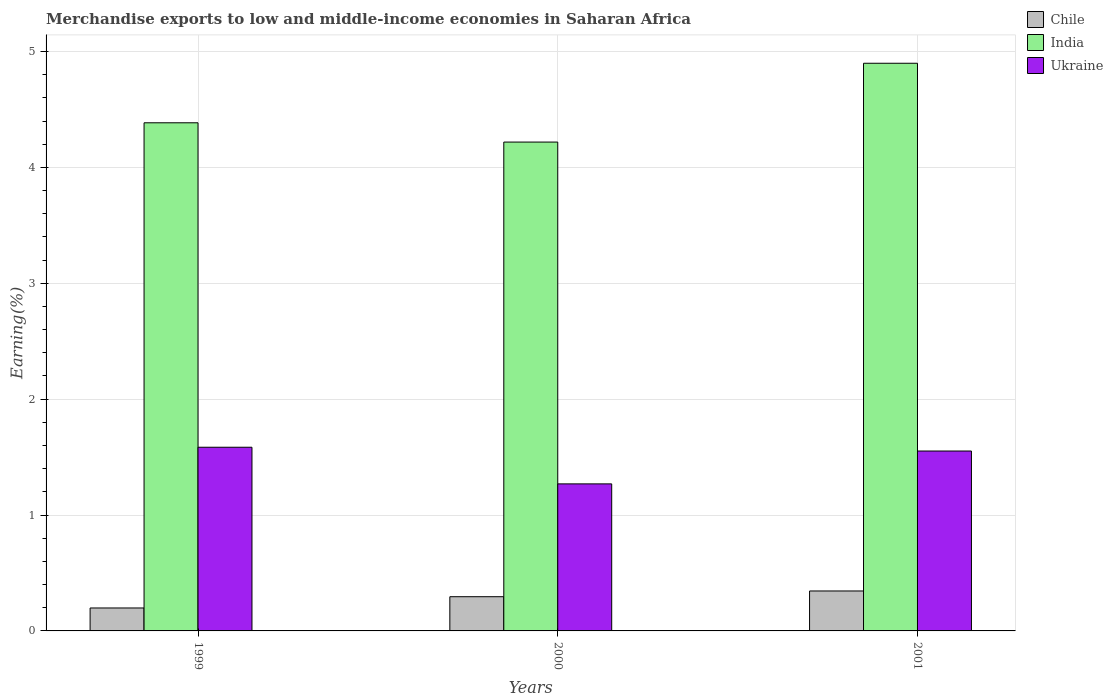How many different coloured bars are there?
Make the answer very short. 3. How many groups of bars are there?
Provide a short and direct response. 3. Are the number of bars per tick equal to the number of legend labels?
Provide a short and direct response. Yes. Are the number of bars on each tick of the X-axis equal?
Give a very brief answer. Yes. How many bars are there on the 2nd tick from the left?
Your response must be concise. 3. What is the percentage of amount earned from merchandise exports in Ukraine in 2000?
Offer a terse response. 1.27. Across all years, what is the maximum percentage of amount earned from merchandise exports in Chile?
Provide a short and direct response. 0.34. Across all years, what is the minimum percentage of amount earned from merchandise exports in Chile?
Provide a short and direct response. 0.2. In which year was the percentage of amount earned from merchandise exports in India maximum?
Keep it short and to the point. 2001. What is the total percentage of amount earned from merchandise exports in Ukraine in the graph?
Keep it short and to the point. 4.41. What is the difference between the percentage of amount earned from merchandise exports in Chile in 1999 and that in 2001?
Provide a short and direct response. -0.15. What is the difference between the percentage of amount earned from merchandise exports in Chile in 2000 and the percentage of amount earned from merchandise exports in Ukraine in 2001?
Your answer should be compact. -1.26. What is the average percentage of amount earned from merchandise exports in Ukraine per year?
Keep it short and to the point. 1.47. In the year 1999, what is the difference between the percentage of amount earned from merchandise exports in Ukraine and percentage of amount earned from merchandise exports in Chile?
Your answer should be very brief. 1.39. In how many years, is the percentage of amount earned from merchandise exports in Ukraine greater than 2.2 %?
Your answer should be compact. 0. What is the ratio of the percentage of amount earned from merchandise exports in Chile in 1999 to that in 2000?
Offer a terse response. 0.67. What is the difference between the highest and the second highest percentage of amount earned from merchandise exports in India?
Keep it short and to the point. 0.51. What is the difference between the highest and the lowest percentage of amount earned from merchandise exports in India?
Keep it short and to the point. 0.68. What does the 3rd bar from the left in 1999 represents?
Your answer should be very brief. Ukraine. Is it the case that in every year, the sum of the percentage of amount earned from merchandise exports in India and percentage of amount earned from merchandise exports in Ukraine is greater than the percentage of amount earned from merchandise exports in Chile?
Ensure brevity in your answer.  Yes. How many bars are there?
Offer a terse response. 9. Are all the bars in the graph horizontal?
Offer a very short reply. No. How many years are there in the graph?
Your answer should be compact. 3. What is the difference between two consecutive major ticks on the Y-axis?
Make the answer very short. 1. Where does the legend appear in the graph?
Offer a terse response. Top right. How are the legend labels stacked?
Keep it short and to the point. Vertical. What is the title of the graph?
Offer a very short reply. Merchandise exports to low and middle-income economies in Saharan Africa. Does "Brunei Darussalam" appear as one of the legend labels in the graph?
Make the answer very short. No. What is the label or title of the X-axis?
Provide a succinct answer. Years. What is the label or title of the Y-axis?
Keep it short and to the point. Earning(%). What is the Earning(%) of Chile in 1999?
Your answer should be very brief. 0.2. What is the Earning(%) in India in 1999?
Give a very brief answer. 4.39. What is the Earning(%) in Ukraine in 1999?
Keep it short and to the point. 1.59. What is the Earning(%) in Chile in 2000?
Your answer should be very brief. 0.3. What is the Earning(%) in India in 2000?
Your answer should be compact. 4.22. What is the Earning(%) in Ukraine in 2000?
Keep it short and to the point. 1.27. What is the Earning(%) in Chile in 2001?
Provide a succinct answer. 0.34. What is the Earning(%) of India in 2001?
Give a very brief answer. 4.9. What is the Earning(%) of Ukraine in 2001?
Provide a short and direct response. 1.55. Across all years, what is the maximum Earning(%) in Chile?
Your response must be concise. 0.34. Across all years, what is the maximum Earning(%) of India?
Your answer should be very brief. 4.9. Across all years, what is the maximum Earning(%) in Ukraine?
Keep it short and to the point. 1.59. Across all years, what is the minimum Earning(%) in Chile?
Your answer should be compact. 0.2. Across all years, what is the minimum Earning(%) in India?
Ensure brevity in your answer.  4.22. Across all years, what is the minimum Earning(%) in Ukraine?
Make the answer very short. 1.27. What is the total Earning(%) of Chile in the graph?
Provide a short and direct response. 0.84. What is the total Earning(%) in India in the graph?
Your answer should be very brief. 13.5. What is the total Earning(%) of Ukraine in the graph?
Your answer should be very brief. 4.41. What is the difference between the Earning(%) of Chile in 1999 and that in 2000?
Your answer should be very brief. -0.1. What is the difference between the Earning(%) of India in 1999 and that in 2000?
Your response must be concise. 0.17. What is the difference between the Earning(%) in Ukraine in 1999 and that in 2000?
Offer a very short reply. 0.32. What is the difference between the Earning(%) in Chile in 1999 and that in 2001?
Provide a succinct answer. -0.15. What is the difference between the Earning(%) of India in 1999 and that in 2001?
Offer a terse response. -0.51. What is the difference between the Earning(%) of Ukraine in 1999 and that in 2001?
Give a very brief answer. 0.03. What is the difference between the Earning(%) of Chile in 2000 and that in 2001?
Your response must be concise. -0.05. What is the difference between the Earning(%) in India in 2000 and that in 2001?
Make the answer very short. -0.68. What is the difference between the Earning(%) in Ukraine in 2000 and that in 2001?
Your answer should be very brief. -0.28. What is the difference between the Earning(%) of Chile in 1999 and the Earning(%) of India in 2000?
Make the answer very short. -4.02. What is the difference between the Earning(%) in Chile in 1999 and the Earning(%) in Ukraine in 2000?
Make the answer very short. -1.07. What is the difference between the Earning(%) in India in 1999 and the Earning(%) in Ukraine in 2000?
Offer a very short reply. 3.12. What is the difference between the Earning(%) of Chile in 1999 and the Earning(%) of India in 2001?
Provide a short and direct response. -4.7. What is the difference between the Earning(%) of Chile in 1999 and the Earning(%) of Ukraine in 2001?
Your answer should be very brief. -1.35. What is the difference between the Earning(%) of India in 1999 and the Earning(%) of Ukraine in 2001?
Offer a very short reply. 2.83. What is the difference between the Earning(%) of Chile in 2000 and the Earning(%) of India in 2001?
Give a very brief answer. -4.6. What is the difference between the Earning(%) in Chile in 2000 and the Earning(%) in Ukraine in 2001?
Provide a short and direct response. -1.26. What is the difference between the Earning(%) of India in 2000 and the Earning(%) of Ukraine in 2001?
Your response must be concise. 2.67. What is the average Earning(%) of Chile per year?
Offer a very short reply. 0.28. What is the average Earning(%) of India per year?
Offer a very short reply. 4.5. What is the average Earning(%) of Ukraine per year?
Your response must be concise. 1.47. In the year 1999, what is the difference between the Earning(%) of Chile and Earning(%) of India?
Keep it short and to the point. -4.19. In the year 1999, what is the difference between the Earning(%) in Chile and Earning(%) in Ukraine?
Provide a short and direct response. -1.39. In the year 2000, what is the difference between the Earning(%) in Chile and Earning(%) in India?
Ensure brevity in your answer.  -3.92. In the year 2000, what is the difference between the Earning(%) of Chile and Earning(%) of Ukraine?
Provide a short and direct response. -0.97. In the year 2000, what is the difference between the Earning(%) in India and Earning(%) in Ukraine?
Your response must be concise. 2.95. In the year 2001, what is the difference between the Earning(%) of Chile and Earning(%) of India?
Make the answer very short. -4.55. In the year 2001, what is the difference between the Earning(%) of Chile and Earning(%) of Ukraine?
Keep it short and to the point. -1.21. In the year 2001, what is the difference between the Earning(%) in India and Earning(%) in Ukraine?
Keep it short and to the point. 3.35. What is the ratio of the Earning(%) in Chile in 1999 to that in 2000?
Give a very brief answer. 0.67. What is the ratio of the Earning(%) of India in 1999 to that in 2000?
Offer a very short reply. 1.04. What is the ratio of the Earning(%) in Ukraine in 1999 to that in 2000?
Provide a short and direct response. 1.25. What is the ratio of the Earning(%) of Chile in 1999 to that in 2001?
Give a very brief answer. 0.57. What is the ratio of the Earning(%) in India in 1999 to that in 2001?
Provide a succinct answer. 0.9. What is the ratio of the Earning(%) in Chile in 2000 to that in 2001?
Make the answer very short. 0.86. What is the ratio of the Earning(%) of India in 2000 to that in 2001?
Provide a succinct answer. 0.86. What is the ratio of the Earning(%) of Ukraine in 2000 to that in 2001?
Provide a succinct answer. 0.82. What is the difference between the highest and the second highest Earning(%) of Chile?
Offer a very short reply. 0.05. What is the difference between the highest and the second highest Earning(%) in India?
Your response must be concise. 0.51. What is the difference between the highest and the second highest Earning(%) of Ukraine?
Keep it short and to the point. 0.03. What is the difference between the highest and the lowest Earning(%) of Chile?
Offer a terse response. 0.15. What is the difference between the highest and the lowest Earning(%) in India?
Provide a succinct answer. 0.68. What is the difference between the highest and the lowest Earning(%) of Ukraine?
Your answer should be compact. 0.32. 